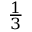<formula> <loc_0><loc_0><loc_500><loc_500>\frac { 1 } { 3 }</formula> 